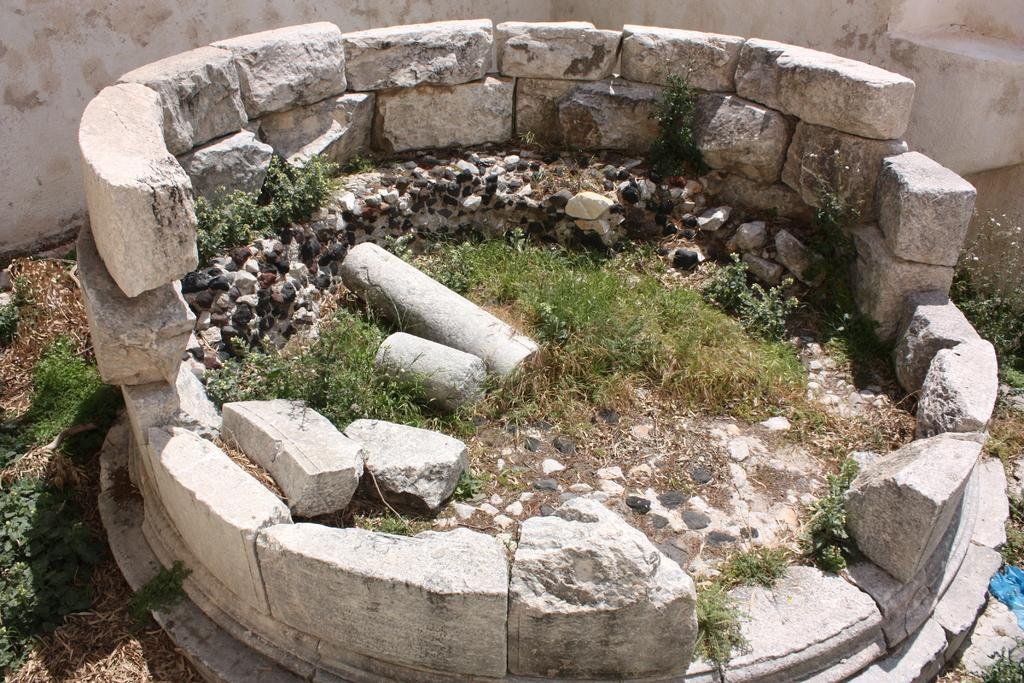Where was the picture taken? The picture was clicked outside. What is the main subject in the center of the image? There are stones in the center of the image. What type of vegetation can be seen in the image? There is grass, plants, and dry stems in the image. What other elements are present in the image? There are rocks in the image. What can be seen in the background of the image? A: There is a wall in the background of the image. What type of beef is being served on the lettuce in the image? There is no beef or lettuce present in the image. Is there a scarecrow standing among the plants in the image? There is no scarecrow present in the image. 